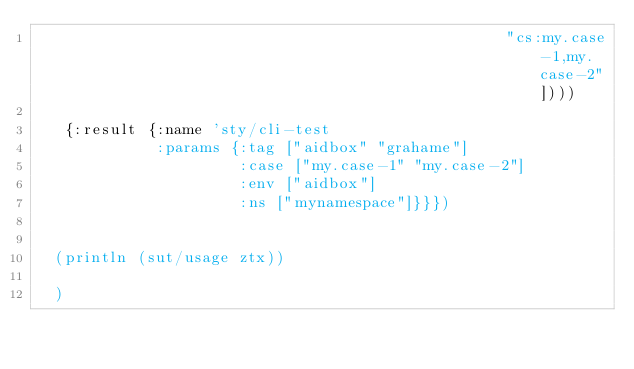<code> <loc_0><loc_0><loc_500><loc_500><_Clojure_>                                                   "cs:my.case-1,my.case-2"])))

   {:result {:name 'sty/cli-test
             :params {:tag ["aidbox" "grahame"]
                      :case ["my.case-1" "my.case-2"]
                      :env ["aidbox"]
                      :ns ["mynamespace"]}}})


  (println (sut/usage ztx))

  )
</code> 